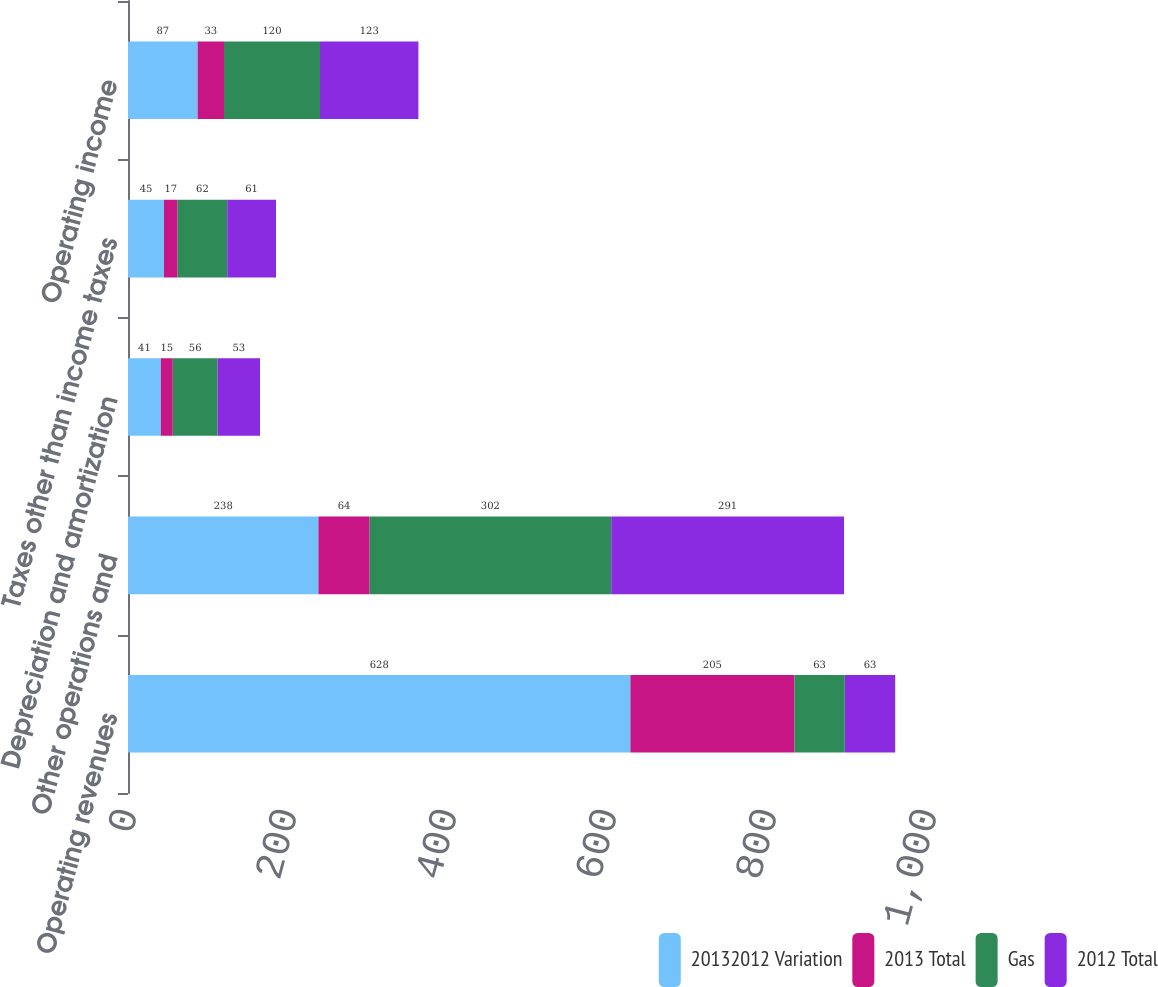<chart> <loc_0><loc_0><loc_500><loc_500><stacked_bar_chart><ecel><fcel>Operating revenues<fcel>Other operations and<fcel>Depreciation and amortization<fcel>Taxes other than income taxes<fcel>Operating income<nl><fcel>20132012 Variation<fcel>628<fcel>238<fcel>41<fcel>45<fcel>87<nl><fcel>2013 Total<fcel>205<fcel>64<fcel>15<fcel>17<fcel>33<nl><fcel>Gas<fcel>63<fcel>302<fcel>56<fcel>62<fcel>120<nl><fcel>2012 Total<fcel>63<fcel>291<fcel>53<fcel>61<fcel>123<nl></chart> 